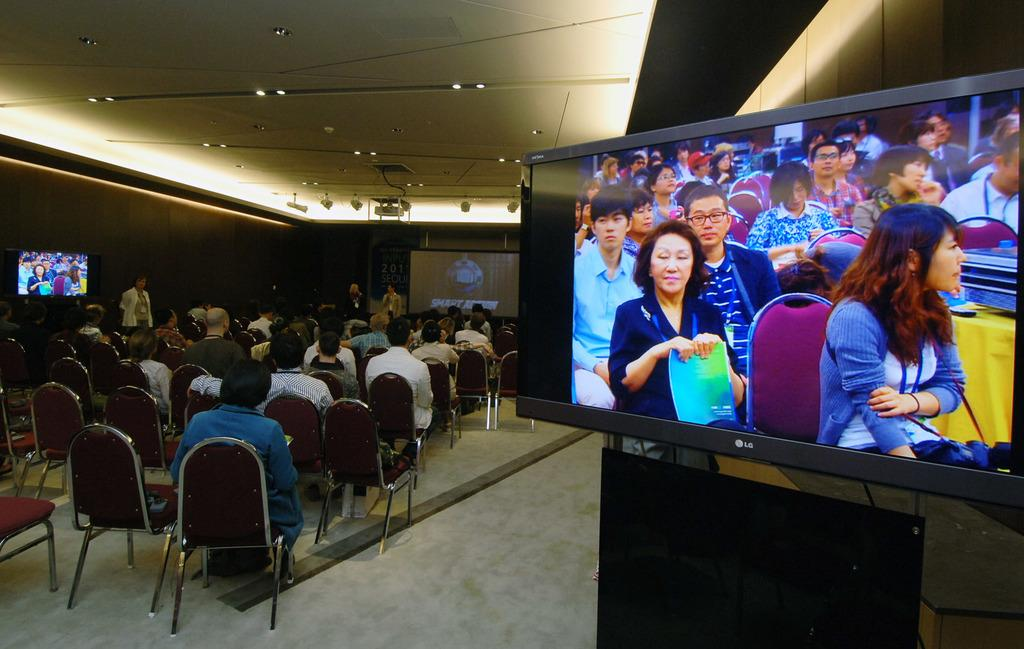How many people are in the image? There are many people in the image. What are the people doing in the image? The people are sitting on chairs. What electronic devices can be seen in the image? There is a TV and a projector in the image. What color is the sock on the person's foot in the image? There is no sock visible in the image. What type of cap is the person wearing in the image? There is no cap visible in the image. 